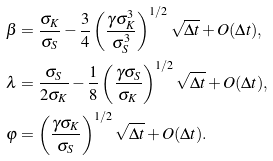Convert formula to latex. <formula><loc_0><loc_0><loc_500><loc_500>\beta & = \frac { \sigma _ { K } } { \sigma _ { S } } - \frac { 3 } { 4 } \left ( \frac { \gamma \sigma _ { K } ^ { 3 } } { \sigma _ { S } ^ { 3 } } \right ) ^ { 1 / 2 } \sqrt { \Delta t } + O ( \Delta t ) , \\ \lambda & = \frac { \sigma _ { S } } { 2 \sigma _ { K } } - \frac { 1 } { 8 } \left ( \frac { \gamma \sigma _ { S } } { \sigma _ { K } } \right ) ^ { 1 / 2 } \sqrt { \Delta t } + O ( \Delta t ) , \\ \varphi & = \left ( \frac { \gamma \sigma _ { K } } { \sigma _ { S } } \right ) ^ { 1 / 2 } \sqrt { \Delta t } + O ( \Delta t ) .</formula> 